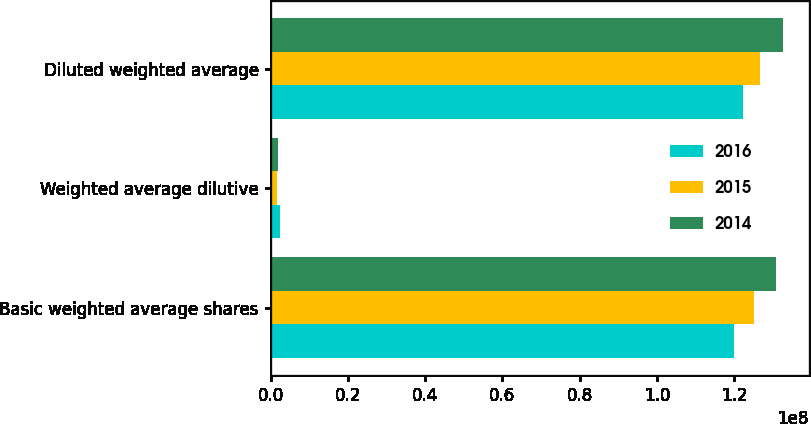<chart> <loc_0><loc_0><loc_500><loc_500><stacked_bar_chart><ecel><fcel>Basic weighted average shares<fcel>Weighted average dilutive<fcel>Diluted weighted average<nl><fcel>2016<fcel>1.20001e+08<fcel>2.36659e+06<fcel>1.22368e+08<nl><fcel>2015<fcel>1.25095e+08<fcel>1.66261e+06<fcel>1.26757e+08<nl><fcel>2014<fcel>1.30722e+08<fcel>1.91851e+06<fcel>1.3264e+08<nl></chart> 